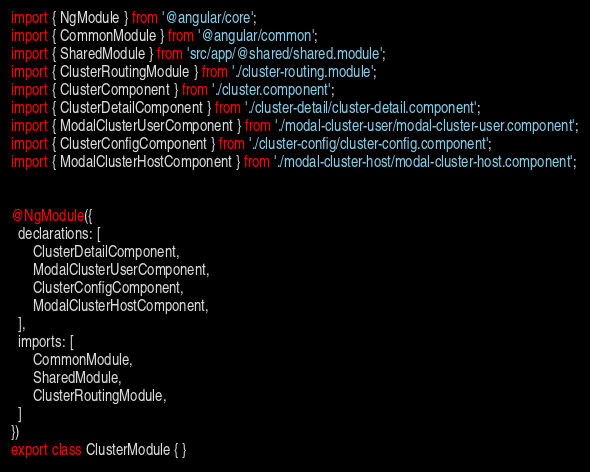Convert code to text. <code><loc_0><loc_0><loc_500><loc_500><_TypeScript_>import { NgModule } from '@angular/core';
import { CommonModule } from '@angular/common';
import { SharedModule } from 'src/app/@shared/shared.module';
import { ClusterRoutingModule } from './cluster-routing.module';
import { ClusterComponent } from './cluster.component';
import { ClusterDetailComponent } from './cluster-detail/cluster-detail.component';
import { ModalClusterUserComponent } from './modal-cluster-user/modal-cluster-user.component';
import { ClusterConfigComponent } from './cluster-config/cluster-config.component';
import { ModalClusterHostComponent } from './modal-cluster-host/modal-cluster-host.component';


@NgModule({
  declarations: [
      ClusterDetailComponent,
      ModalClusterUserComponent,
      ClusterConfigComponent,
      ModalClusterHostComponent,
  ],
  imports: [
      CommonModule,
      SharedModule,
      ClusterRoutingModule,
  ]
})
export class ClusterModule { }
</code> 